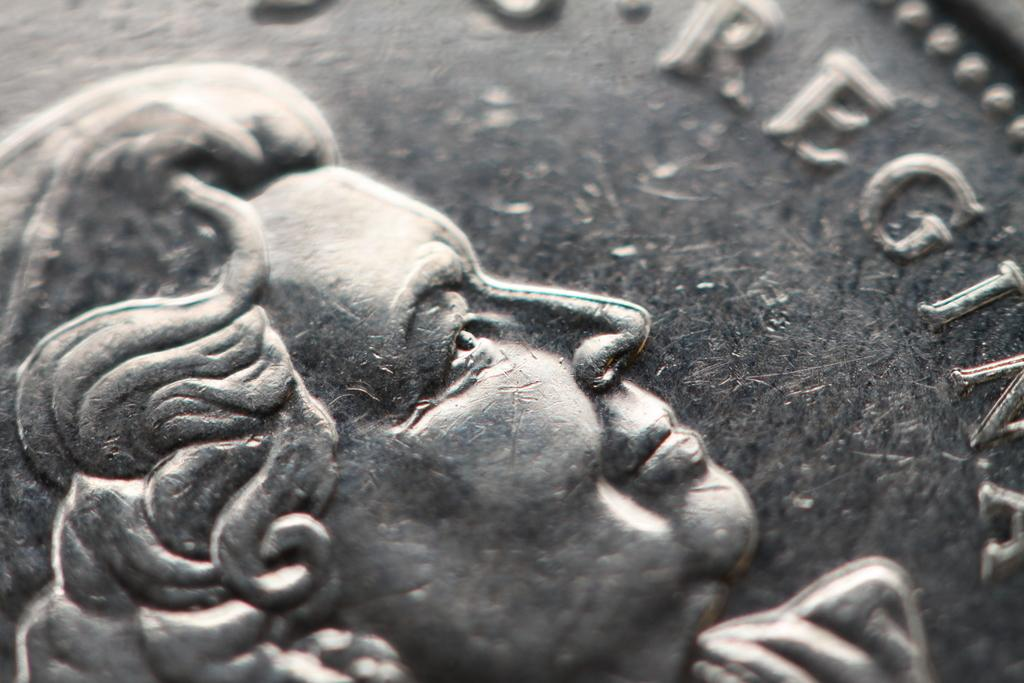What is the main subject of the image? The main subject of the image is a sculpture of a person's face. Can you describe any other objects or features in the image? Yes, there is text on a coin in the image. What type of grain is being harvested in the image? There is no grain or harvesting activity present in the image; it features a sculpture of a person's face and text on a coin. 